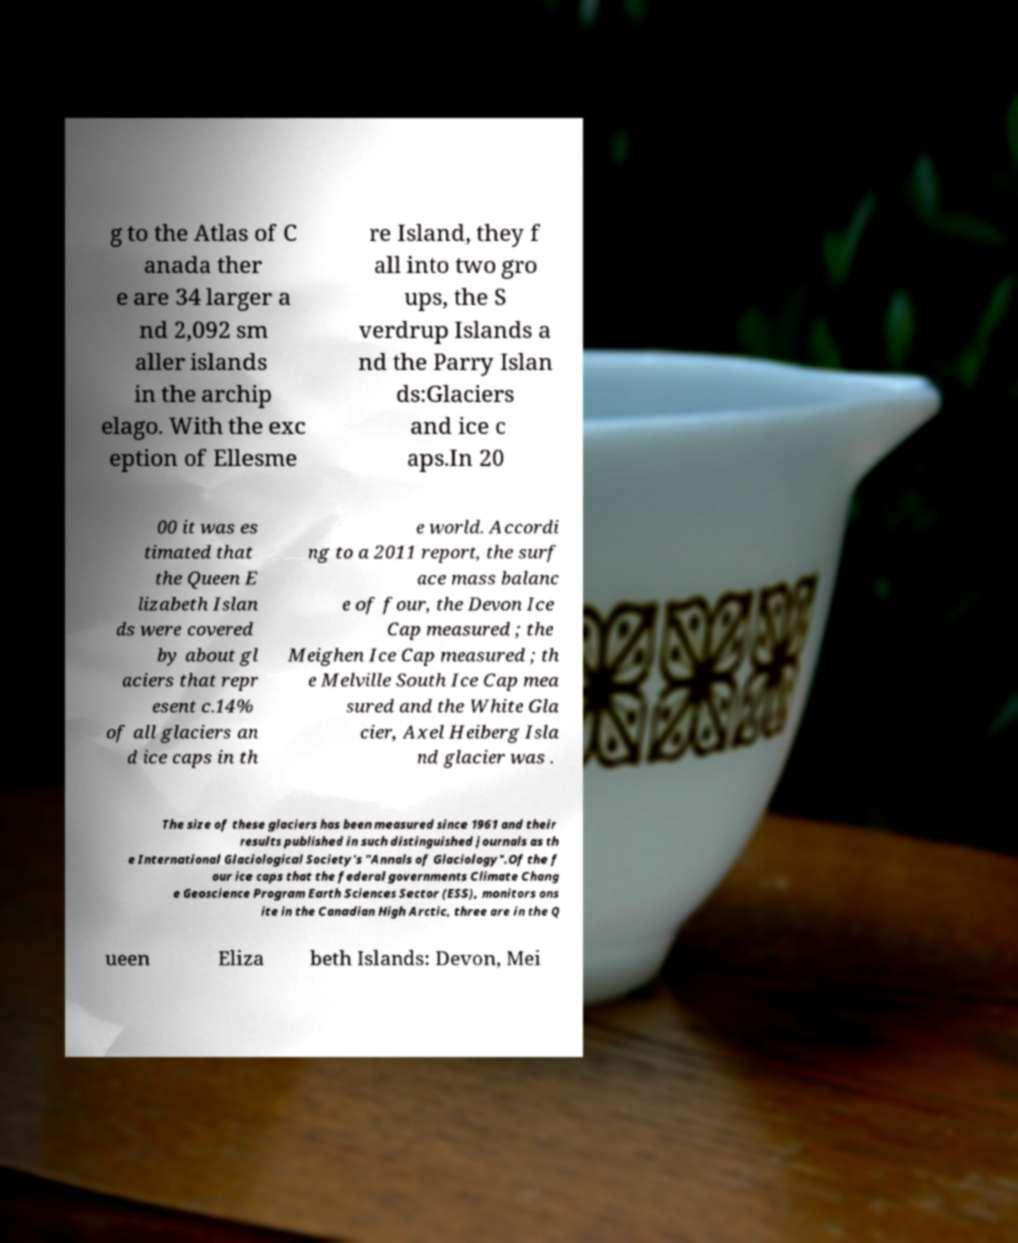There's text embedded in this image that I need extracted. Can you transcribe it verbatim? g to the Atlas of C anada ther e are 34 larger a nd 2,092 sm aller islands in the archip elago. With the exc eption of Ellesme re Island, they f all into two gro ups, the S verdrup Islands a nd the Parry Islan ds:Glaciers and ice c aps.In 20 00 it was es timated that the Queen E lizabeth Islan ds were covered by about gl aciers that repr esent c.14% of all glaciers an d ice caps in th e world. Accordi ng to a 2011 report, the surf ace mass balanc e of four, the Devon Ice Cap measured ; the Meighen Ice Cap measured ; th e Melville South Ice Cap mea sured and the White Gla cier, Axel Heiberg Isla nd glacier was . The size of these glaciers has been measured since 1961 and their results published in such distinguished journals as th e International Glaciological Society's "Annals of Glaciology".Of the f our ice caps that the federal governments Climate Chang e Geoscience Program Earth Sciences Sector (ESS), monitors ons ite in the Canadian High Arctic, three are in the Q ueen Eliza beth Islands: Devon, Mei 